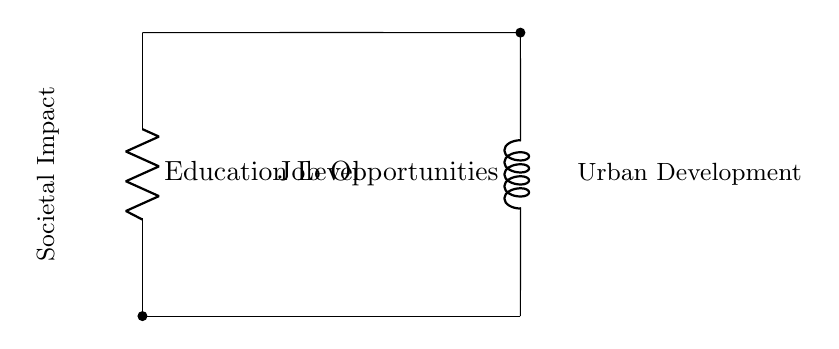What does R represent in the circuit? R represents the resistance related to education levels in the context of employment rates. It is indicative of how education levels influence employment opportunities.
Answer: Education Level What does L signify in the circuit? L signifies the inductance related to job opportunities, suggesting that job opportunities can be influenced by dynamic factors such as economic conditions and market demand.
Answer: Job Opportunities What is the relationship between R and L in this circuit? The relationship indicates a parallel arrangement where both the resistance (education level) and inductance (job opportunities) have individual paths influencing the overall societal impact and urban development.
Answer: Parallel interaction How might increasing R affect urban development? An increase in R, or education levels, could lead to more employment opportunities, thereby positively impacting urban development. It suggests an enhancement in societal conditions through better education.
Answer: Positive impact If current flows through R, what effect might it have on employment rates? Current flowing through R indicates that as education levels improve, there is likely a corresponding increase in employment rates, reflecting a direct correlation between education and job availability.
Answer: Increase in employment rates What societal issue does this circuit model? This circuit models the interaction between education levels and employment rates, illustrating how these factors contribute to urban issues.
Answer: Education and employment interaction How can this circuit help in urban development strategies? Understanding the dynamic relationship between R and L in the circuit allows policymakers to focus on improving education levels to boost employment, directly influencing urban development strategies.
Answer: Inform urban strategies 